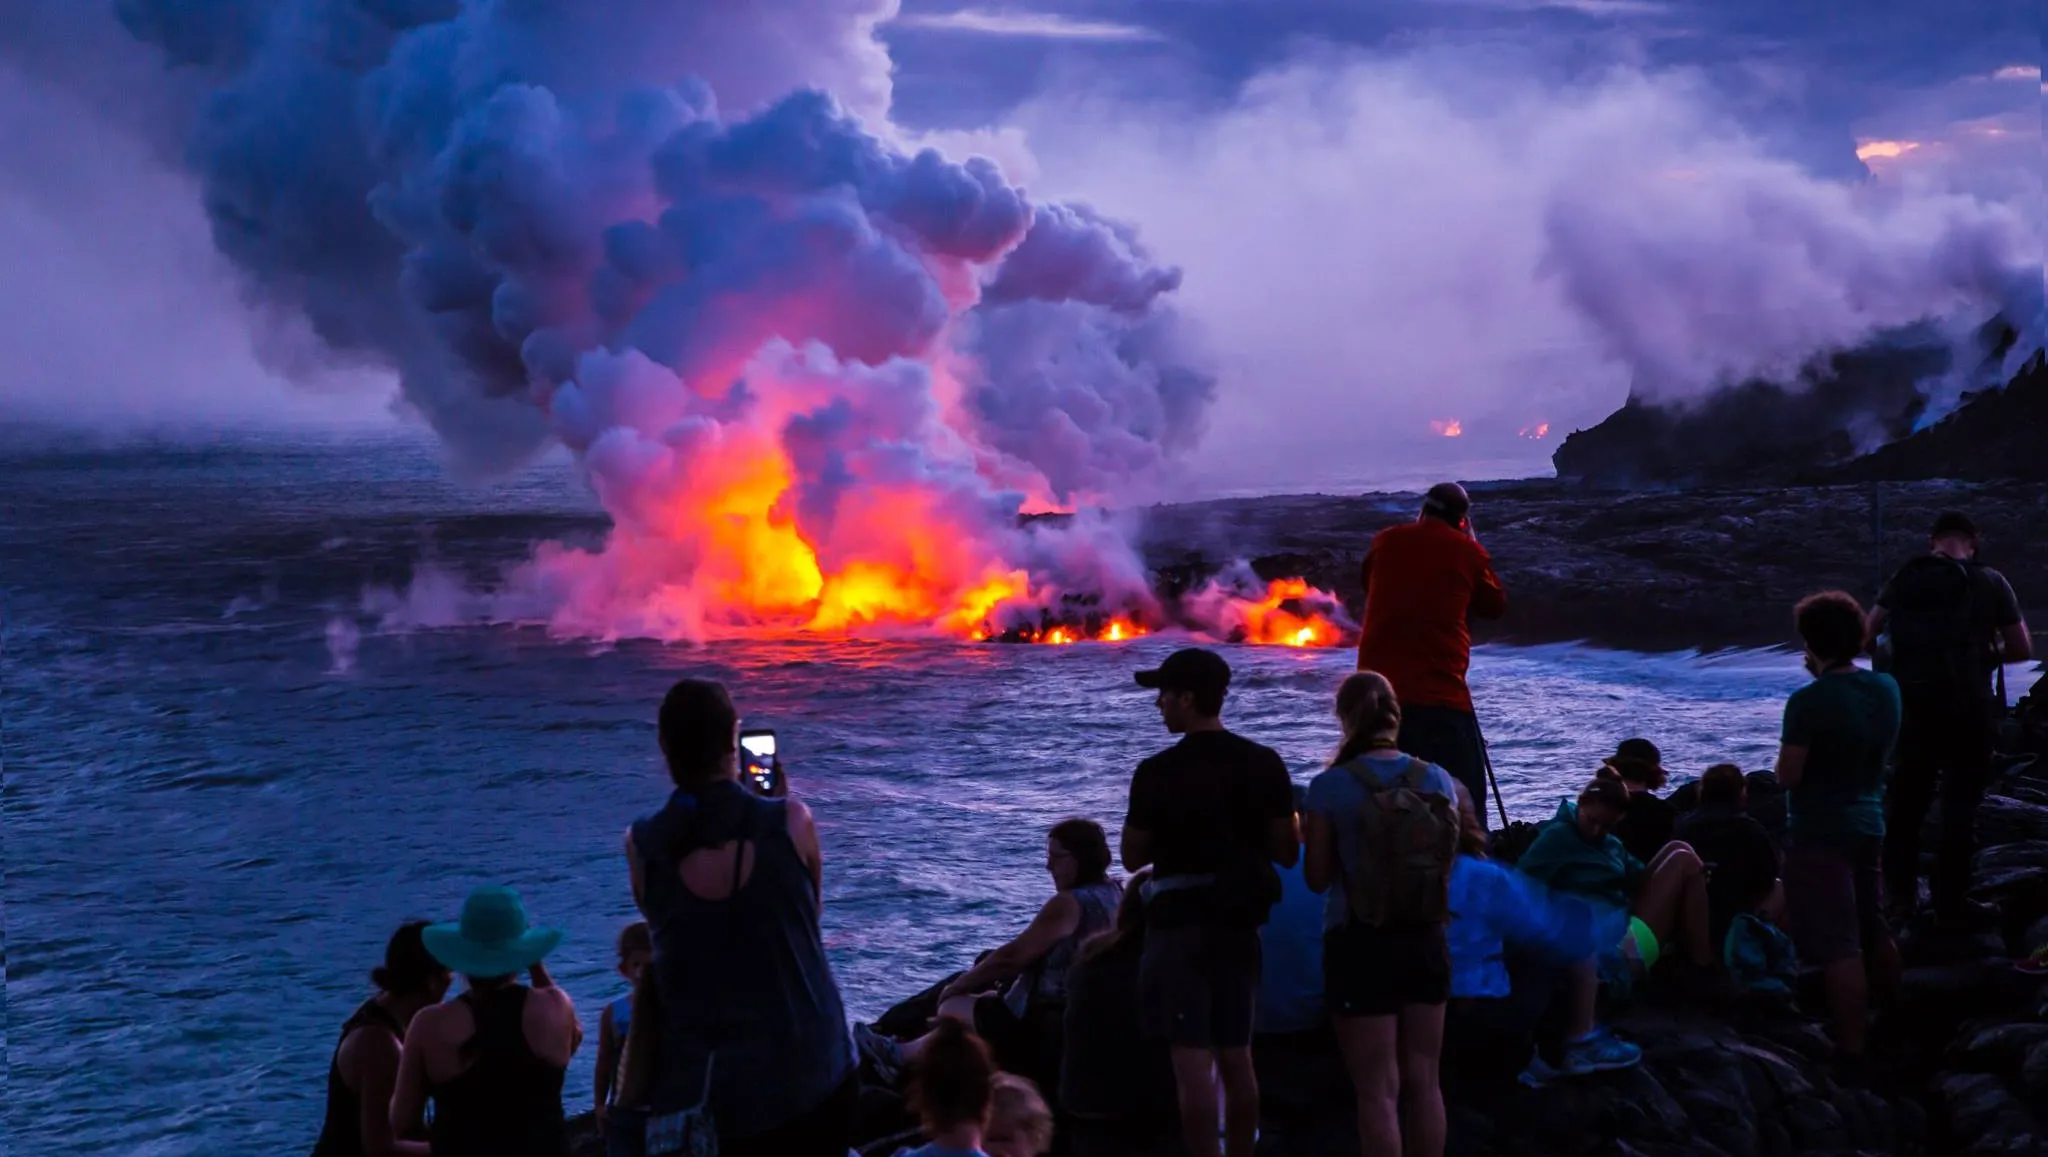How might the temperature vary between the location of the people and the site of the volcanic eruption? The temperature at the site of the eruption is significantly higher due to the molten lava and steam. People standing at a safe distance would experience cooler temperatures, especially with the ocean breeze, though they may still feel warmth from the radiating heat of the lava. 